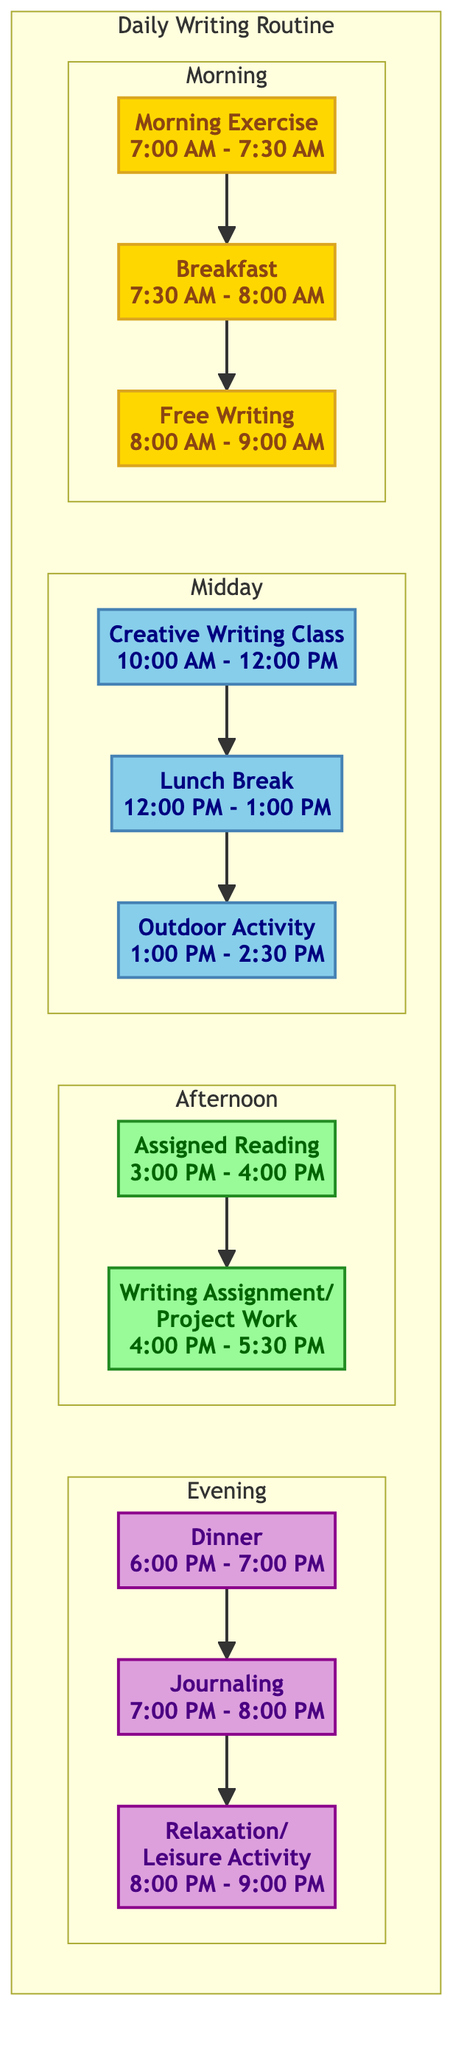What is the first task in the Morning block? The first task listed in the Morning block is "Morning Exercise," which appears at the top of the Morning subgraph.
Answer: Morning Exercise How long does the Free Writing task last? The Free Writing task starts at 8:00 AM and ends at 9:00 AM, making it last for 1 hour.
Answer: 1 hour How many tasks are there in the Midday block? The Midday block contains three tasks: Creative Writing Class, Lunch Break, and Outdoor Activity. Counting these tasks gives a total of 3.
Answer: 3 What is the last task in the Evening block? The last task in the Evening block is "Relaxation/Leisure Activity," which is positioned at the bottom of the Evening subgraph.
Answer: Relaxation/Leisure Activity What task occurs just before Dinner? The task that occurs just before Dinner (which is scheduled from 6:00 PM to 7:00 PM) is "Writing Assignment/Project Work," as it is the last task of the Afternoon block just leading into the Evening.
Answer: Writing Assignment/Project Work What is the total time allocated for writing tasks in the Afternoon? In the Afternoon, there are two tasks related to writing: Assigned Reading for 1 hour (3:00 PM to 4:00 PM) and Writing Assignment/Project Work for 1.5 hours (4:00 PM to 5:30 PM). The total time is 1 hour + 1.5 hours = 2.5 hours.
Answer: 2.5 hours Which task is slotted after the Lunch Break? After the Lunch Break, which occurs from 12:00 PM to 1:00 PM, the next task is "Outdoor Activity," starting at 1:00 PM.
Answer: Outdoor Activity How many total blocks are there in the Daily Writing Routine? The Daily Writing Routine comprises four distinct blocks: Morning, Midday, Afternoon, and Evening. By counting these blocks, we find there are a total of 4.
Answer: 4 Which block includes the task "Assigned Reading"? "Assigned Reading" is included in the Afternoon block, as it is listed in the tasks section of that block.
Answer: Afternoon 